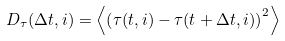Convert formula to latex. <formula><loc_0><loc_0><loc_500><loc_500>D _ { \tau } ( \Delta t , i ) = \left < \left ( \tau ( t , i ) - \tau ( t + \Delta t , i ) \right ) ^ { 2 } \right ></formula> 